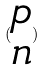Convert formula to latex. <formula><loc_0><loc_0><loc_500><loc_500>( \begin{matrix} p \\ n \end{matrix} )</formula> 